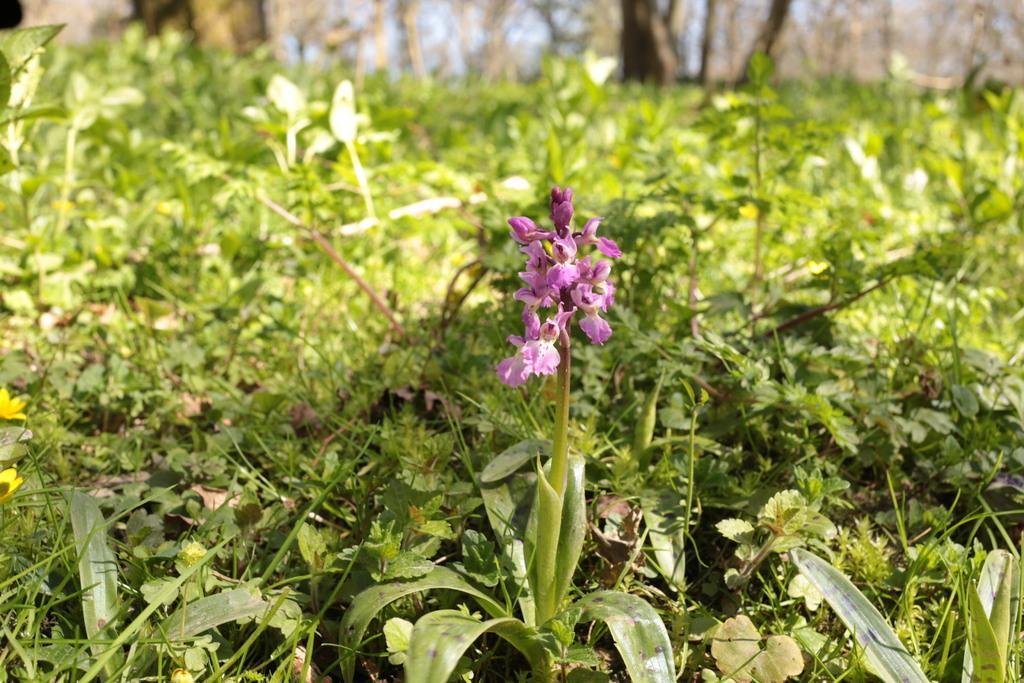Can you describe this image briefly? In the picture there is a lot of grass and in between them there is a plant with beautiful flowers. 